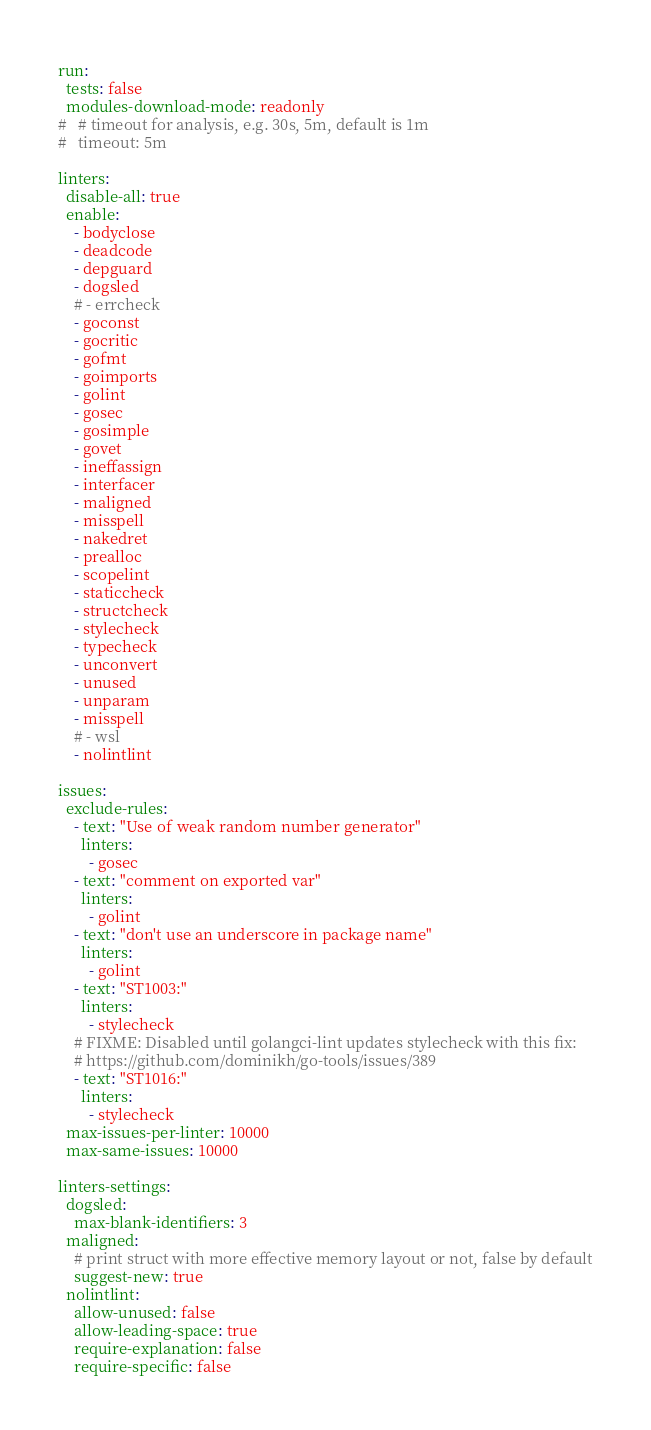<code> <loc_0><loc_0><loc_500><loc_500><_YAML_>run:
  tests: false
  modules-download-mode: readonly
#   # timeout for analysis, e.g. 30s, 5m, default is 1m
#   timeout: 5m

linters:
  disable-all: true
  enable:
    - bodyclose
    - deadcode
    - depguard
    - dogsled
    # - errcheck
    - goconst
    - gocritic
    - gofmt
    - goimports
    - golint
    - gosec
    - gosimple
    - govet
    - ineffassign
    - interfacer
    - maligned
    - misspell
    - nakedret
    - prealloc
    - scopelint
    - staticcheck
    - structcheck
    - stylecheck
    - typecheck
    - unconvert
    - unused
    - unparam
    - misspell
    # - wsl
    - nolintlint

issues:
  exclude-rules:
    - text: "Use of weak random number generator"
      linters:
        - gosec
    - text: "comment on exported var"
      linters:
        - golint
    - text: "don't use an underscore in package name"
      linters:
        - golint
    - text: "ST1003:"
      linters:
        - stylecheck
    # FIXME: Disabled until golangci-lint updates stylecheck with this fix:
    # https://github.com/dominikh/go-tools/issues/389
    - text: "ST1016:"
      linters:
        - stylecheck
  max-issues-per-linter: 10000
  max-same-issues: 10000

linters-settings:
  dogsled:
    max-blank-identifiers: 3
  maligned:
    # print struct with more effective memory layout or not, false by default
    suggest-new: true
  nolintlint:
    allow-unused: false
    allow-leading-space: true
    require-explanation: false
    require-specific: false
</code> 